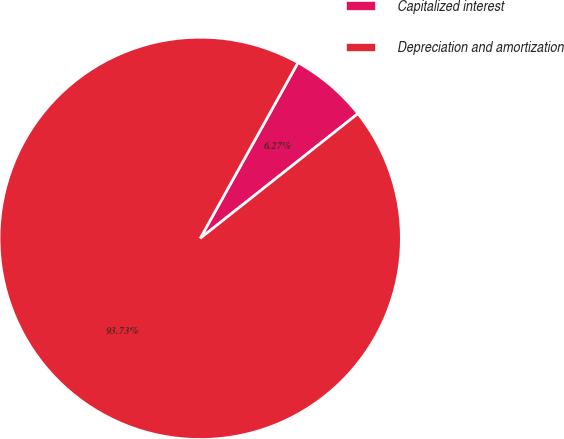<chart> <loc_0><loc_0><loc_500><loc_500><pie_chart><fcel>Capitalized interest<fcel>Depreciation and amortization<nl><fcel>6.27%<fcel>93.73%<nl></chart> 